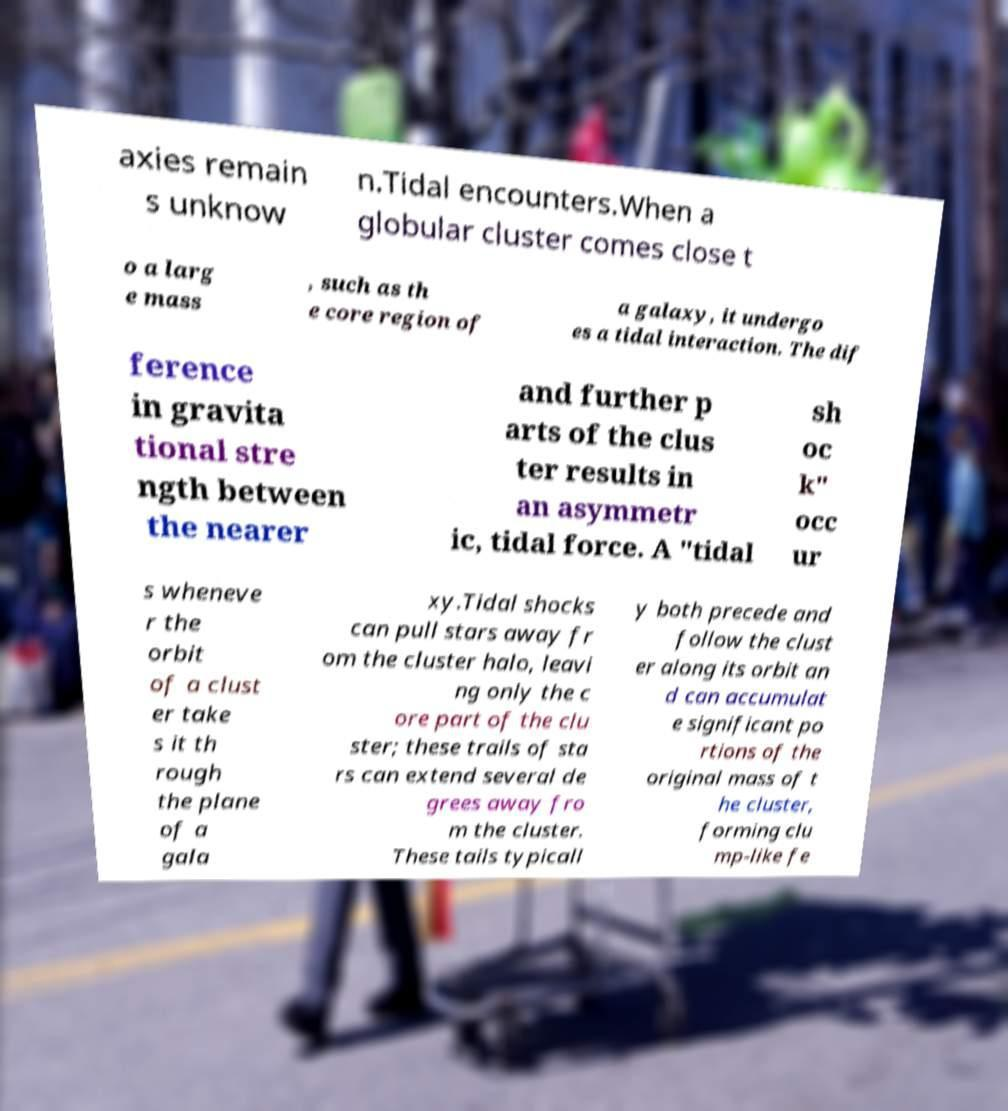Can you accurately transcribe the text from the provided image for me? axies remain s unknow n.Tidal encounters.When a globular cluster comes close t o a larg e mass , such as th e core region of a galaxy, it undergo es a tidal interaction. The dif ference in gravita tional stre ngth between the nearer and further p arts of the clus ter results in an asymmetr ic, tidal force. A "tidal sh oc k" occ ur s wheneve r the orbit of a clust er take s it th rough the plane of a gala xy.Tidal shocks can pull stars away fr om the cluster halo, leavi ng only the c ore part of the clu ster; these trails of sta rs can extend several de grees away fro m the cluster. These tails typicall y both precede and follow the clust er along its orbit an d can accumulat e significant po rtions of the original mass of t he cluster, forming clu mp-like fe 